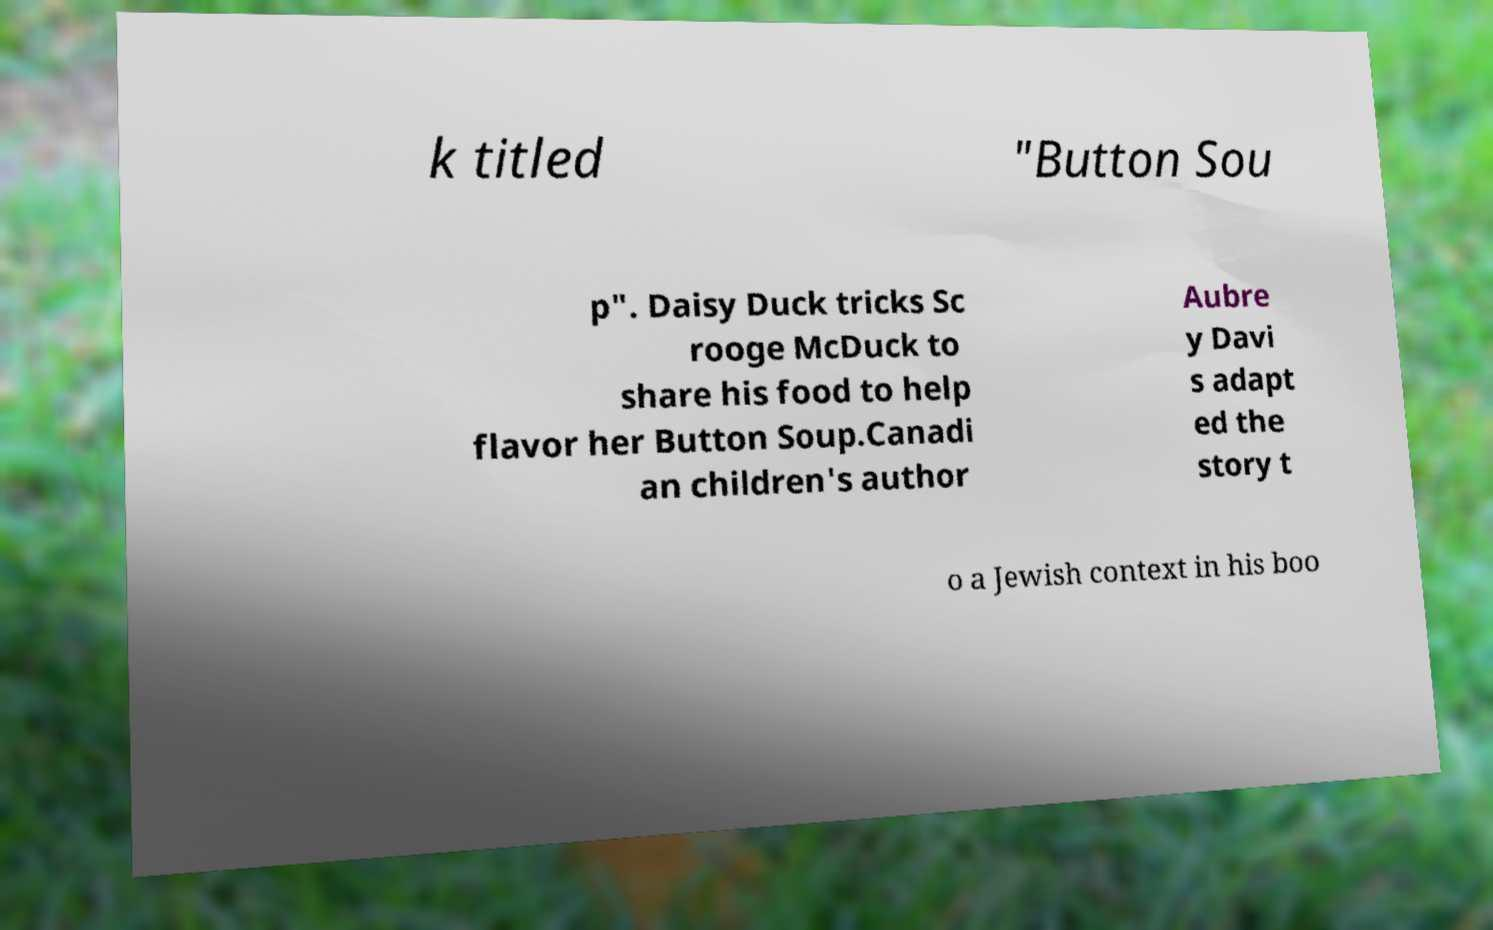Can you read and provide the text displayed in the image?This photo seems to have some interesting text. Can you extract and type it out for me? k titled "Button Sou p". Daisy Duck tricks Sc rooge McDuck to share his food to help flavor her Button Soup.Canadi an children's author Aubre y Davi s adapt ed the story t o a Jewish context in his boo 